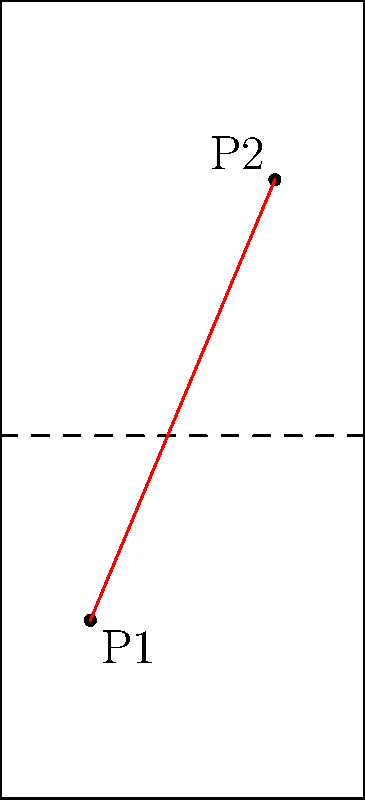In a standard badminton court (13.4m long and 6.1m wide), player P1 is standing 1.5m from the left sideline and 3m from their own baseline. Player P2 is positioned 4.6m from the left sideline and 3m from their own baseline on the opposite side. Calculate the distance between the two players to the nearest centimeter. Let's approach this step-by-step:

1) First, we need to establish a coordinate system. Let's set the bottom-left corner of the court as (0,0).

2) Given the information, we can determine the coordinates of both players:
   P1: (1.5, 3)
   P2: (4.6, 13.4 - 3) = (4.6, 10.4)

3) To find the distance between these two points, we can use the distance formula:

   $$d = \sqrt{(x_2-x_1)^2 + (y_2-y_1)^2}$$

4) Plugging in our values:

   $$d = \sqrt{(4.6-1.5)^2 + (10.4-3)^2}$$

5) Simplify:

   $$d = \sqrt{3.1^2 + 7.4^2}$$

6) Calculate:

   $$d = \sqrt{9.61 + 54.76} = \sqrt{64.37} \approx 8.0230$$

7) Rounding to the nearest centimeter:

   $$d \approx 8.02\text{ m}$$
Answer: 8.02 m 